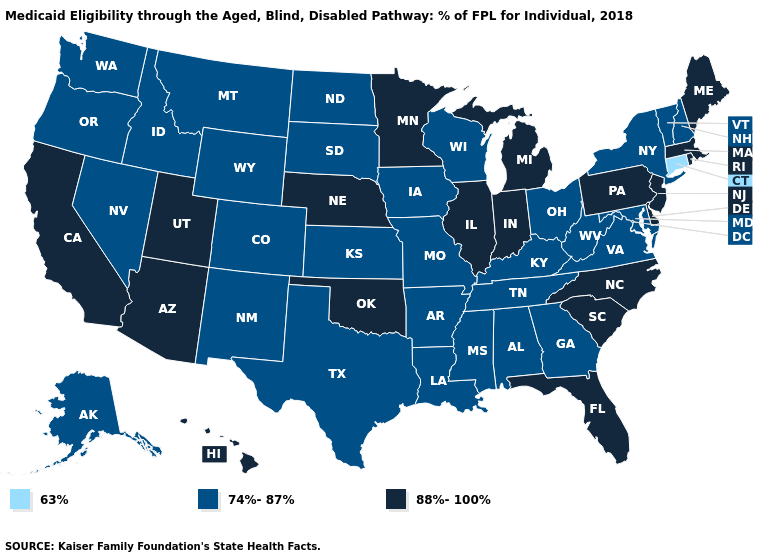Does the map have missing data?
Short answer required. No. Among the states that border Mississippi , which have the lowest value?
Short answer required. Alabama, Arkansas, Louisiana, Tennessee. Among the states that border Nebraska , which have the lowest value?
Be succinct. Colorado, Iowa, Kansas, Missouri, South Dakota, Wyoming. Does South Carolina have the highest value in the South?
Concise answer only. Yes. Name the states that have a value in the range 88%-100%?
Be succinct. Arizona, California, Delaware, Florida, Hawaii, Illinois, Indiana, Maine, Massachusetts, Michigan, Minnesota, Nebraska, New Jersey, North Carolina, Oklahoma, Pennsylvania, Rhode Island, South Carolina, Utah. What is the value of North Carolina?
Short answer required. 88%-100%. What is the value of Washington?
Short answer required. 74%-87%. What is the value of Kentucky?
Give a very brief answer. 74%-87%. What is the value of Nevada?
Give a very brief answer. 74%-87%. Does Louisiana have the same value as Tennessee?
Answer briefly. Yes. What is the value of California?
Be succinct. 88%-100%. What is the value of Connecticut?
Give a very brief answer. 63%. What is the value of Georgia?
Keep it brief. 74%-87%. What is the value of Pennsylvania?
Concise answer only. 88%-100%. What is the highest value in states that border Kentucky?
Answer briefly. 88%-100%. 